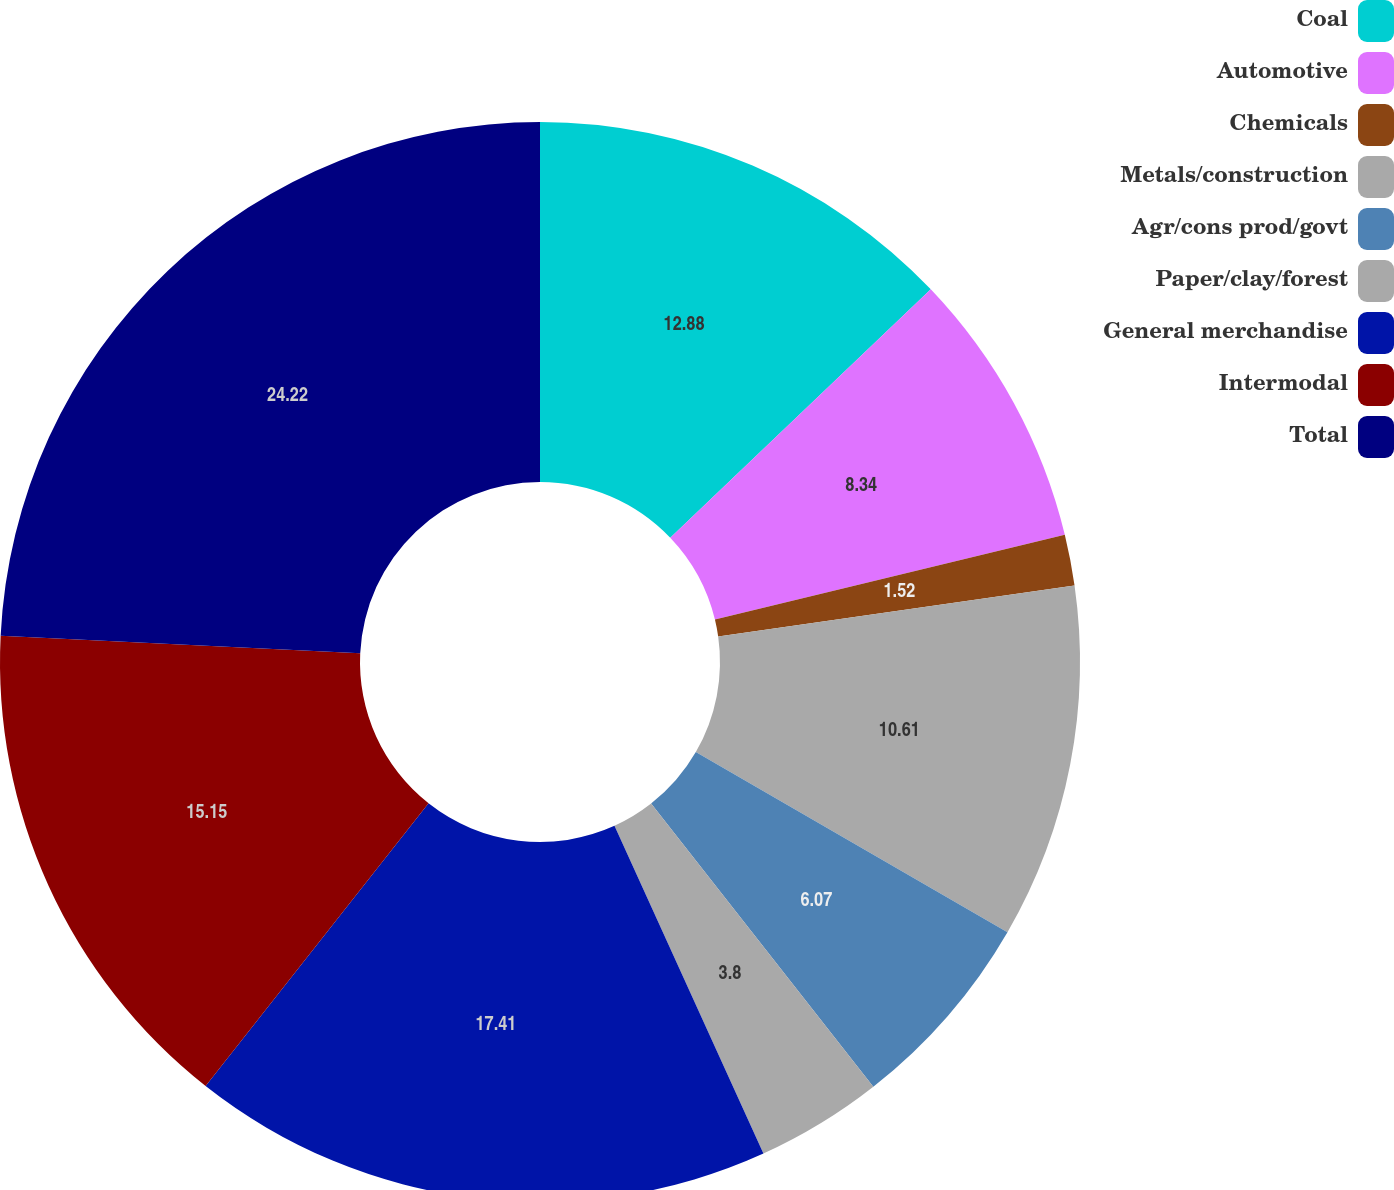Convert chart to OTSL. <chart><loc_0><loc_0><loc_500><loc_500><pie_chart><fcel>Coal<fcel>Automotive<fcel>Chemicals<fcel>Metals/construction<fcel>Agr/cons prod/govt<fcel>Paper/clay/forest<fcel>General merchandise<fcel>Intermodal<fcel>Total<nl><fcel>12.88%<fcel>8.34%<fcel>1.52%<fcel>10.61%<fcel>6.07%<fcel>3.8%<fcel>17.42%<fcel>15.15%<fcel>24.23%<nl></chart> 